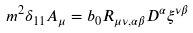<formula> <loc_0><loc_0><loc_500><loc_500>m ^ { 2 } \delta _ { 1 1 } A _ { \mu } = b _ { 0 } R _ { \mu \nu , \alpha \beta } D ^ { \alpha } \xi ^ { \nu \beta }</formula> 